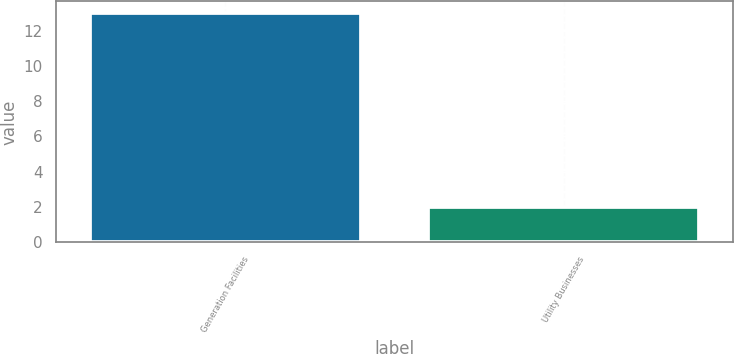<chart> <loc_0><loc_0><loc_500><loc_500><bar_chart><fcel>Generation Facilities<fcel>Utility Businesses<nl><fcel>13<fcel>2<nl></chart> 